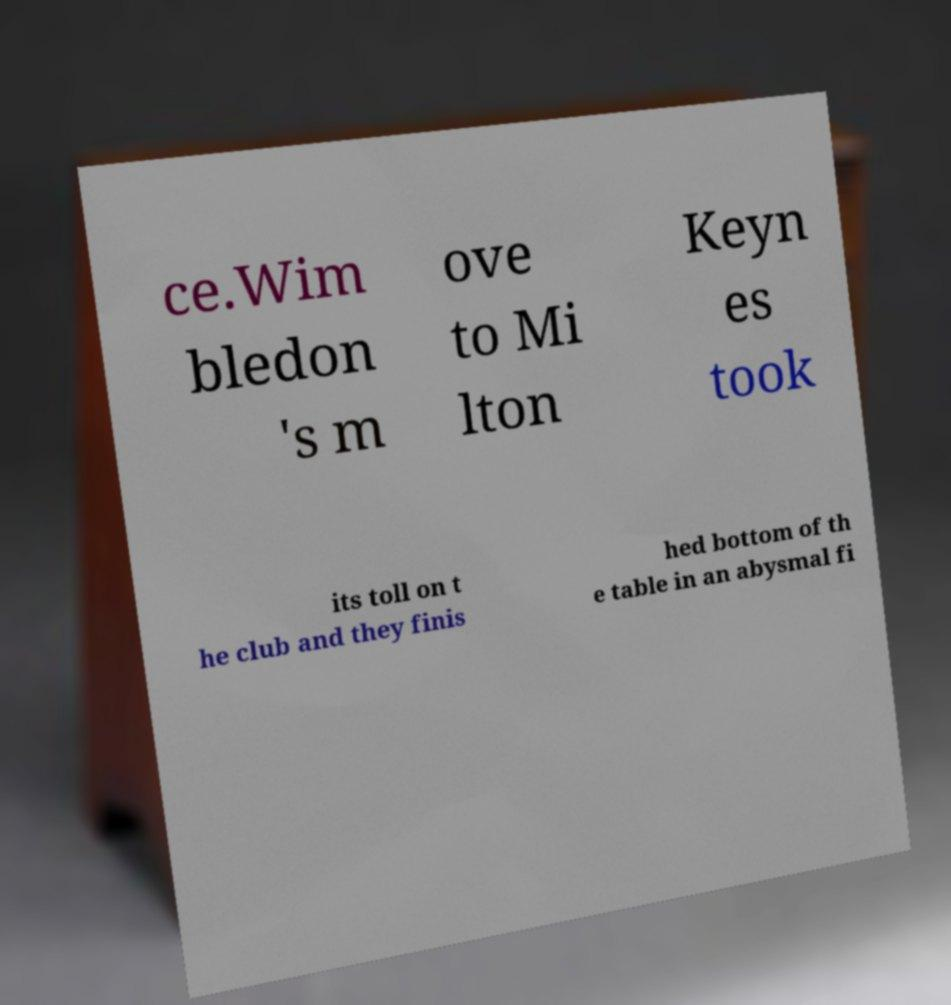Could you assist in decoding the text presented in this image and type it out clearly? ce.Wim bledon 's m ove to Mi lton Keyn es took its toll on t he club and they finis hed bottom of th e table in an abysmal fi 